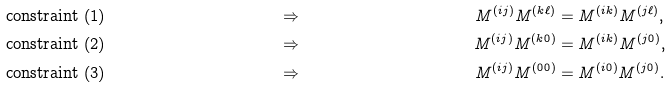<formula> <loc_0><loc_0><loc_500><loc_500>& & \text {constraint (1)} & & & \Rightarrow & M ^ { ( i j ) } M ^ { ( k \ell ) } & = M ^ { ( i k ) } M ^ { ( j \ell ) } , & & \\ & & \text {constraint (2)} & & & \Rightarrow & M ^ { ( i j ) } M ^ { ( k 0 ) } & = M ^ { ( i k ) } M ^ { ( j 0 ) } , & & \\ & & \text {constraint (3)} & & & \Rightarrow & M ^ { ( i j ) } M ^ { ( 0 0 ) } & = M ^ { ( i 0 ) } M ^ { ( j 0 ) } . & &</formula> 